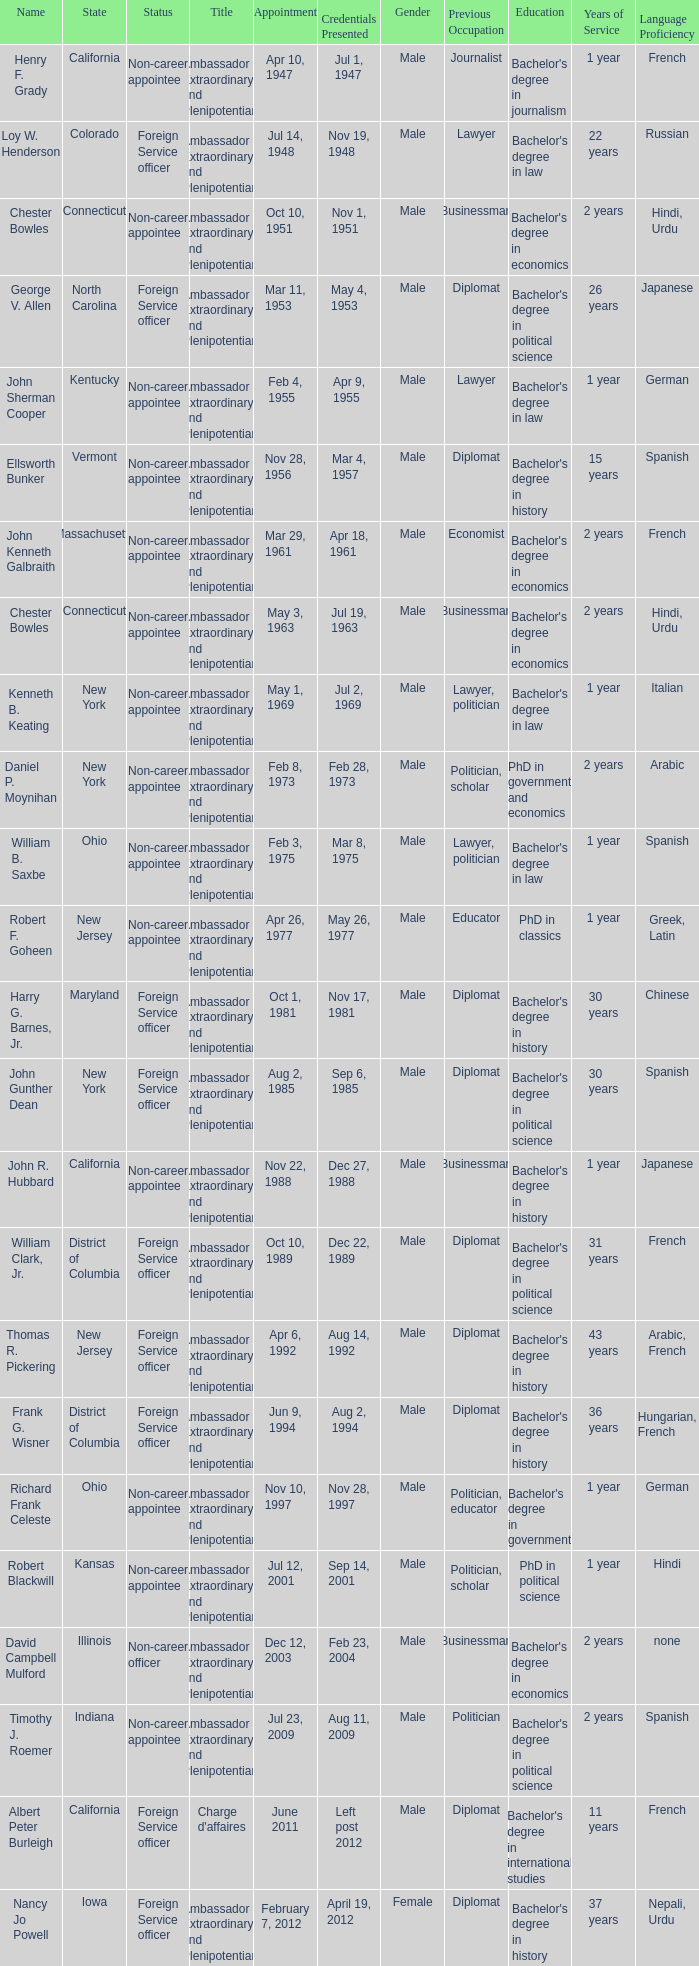What day were credentials presented for vermont? Mar 4, 1957. 